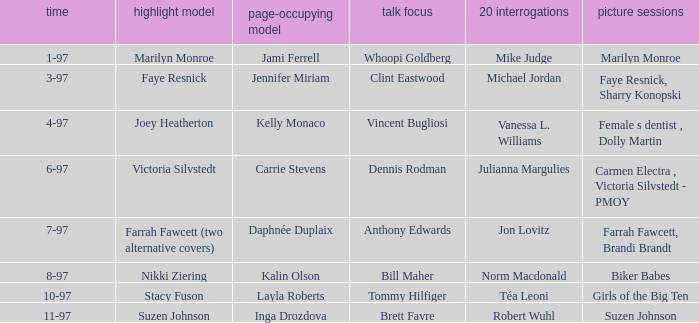Who was the centerfold model when a pictorial was done on marilyn monroe? Jami Ferrell. 